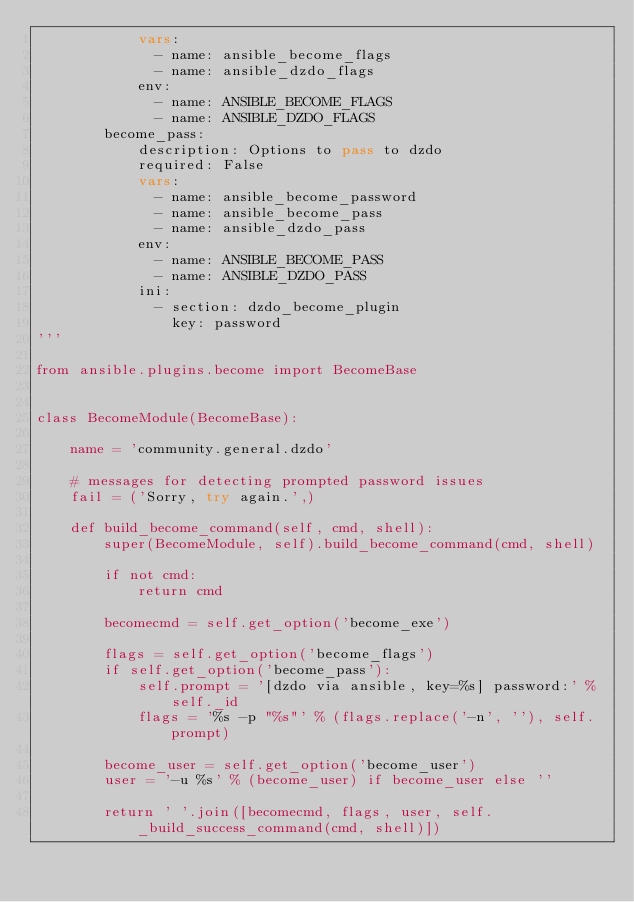<code> <loc_0><loc_0><loc_500><loc_500><_Python_>            vars:
              - name: ansible_become_flags
              - name: ansible_dzdo_flags
            env:
              - name: ANSIBLE_BECOME_FLAGS
              - name: ANSIBLE_DZDO_FLAGS
        become_pass:
            description: Options to pass to dzdo
            required: False
            vars:
              - name: ansible_become_password
              - name: ansible_become_pass
              - name: ansible_dzdo_pass
            env:
              - name: ANSIBLE_BECOME_PASS
              - name: ANSIBLE_DZDO_PASS
            ini:
              - section: dzdo_become_plugin
                key: password
'''

from ansible.plugins.become import BecomeBase


class BecomeModule(BecomeBase):

    name = 'community.general.dzdo'

    # messages for detecting prompted password issues
    fail = ('Sorry, try again.',)

    def build_become_command(self, cmd, shell):
        super(BecomeModule, self).build_become_command(cmd, shell)

        if not cmd:
            return cmd

        becomecmd = self.get_option('become_exe')

        flags = self.get_option('become_flags')
        if self.get_option('become_pass'):
            self.prompt = '[dzdo via ansible, key=%s] password:' % self._id
            flags = '%s -p "%s"' % (flags.replace('-n', ''), self.prompt)

        become_user = self.get_option('become_user')
        user = '-u %s' % (become_user) if become_user else ''

        return ' '.join([becomecmd, flags, user, self._build_success_command(cmd, shell)])
</code> 